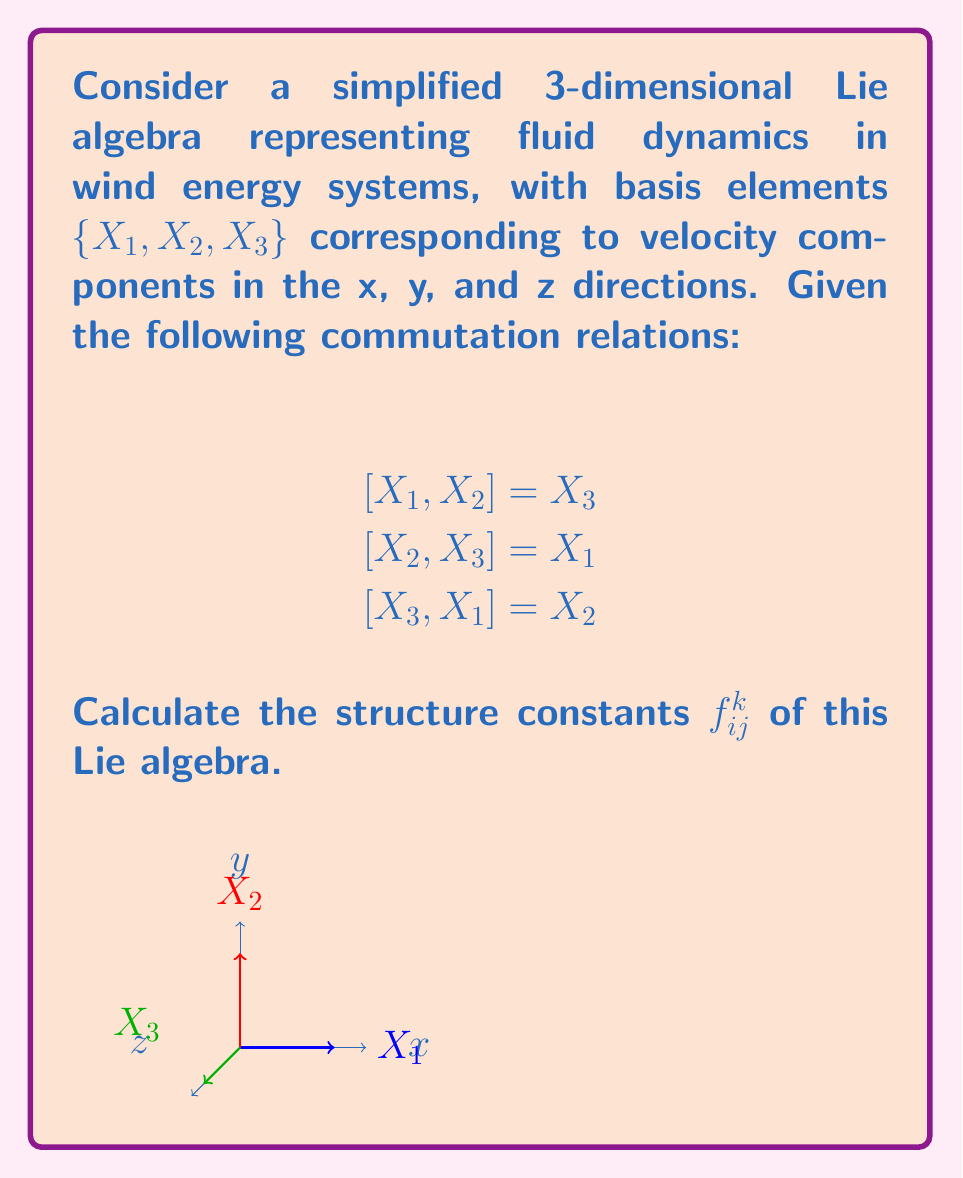Can you solve this math problem? To calculate the structure constants $f_{ij}^k$, we use the general form of the Lie bracket:

$$[X_i, X_j] = \sum_{k=1}^3 f_{ij}^k X_k$$

Step 1: Analyze $[X_1, X_2] = X_3$
This implies $f_{12}^3 = 1$, and $f_{12}^1 = f_{12}^2 = 0$

Step 2: Analyze $[X_2, X_3] = X_1$
This implies $f_{23}^1 = 1$, and $f_{23}^2 = f_{23}^3 = 0$

Step 3: Analyze $[X_3, X_1] = X_2$
This implies $f_{31}^2 = 1$, and $f_{31}^1 = f_{31}^3 = 0$

Step 4: Use the antisymmetry property of Lie brackets
$[X_i, X_j] = -[X_j, X_i]$ implies $f_{ij}^k = -f_{ji}^k$

Thus:
$f_{21}^3 = -1$, $f_{32}^1 = -1$, $f_{13}^2 = -1$

Step 5: All other structure constants are zero

Therefore, the non-zero structure constants are:
$f_{12}^3 = f_{23}^1 = f_{31}^2 = 1$
$f_{21}^3 = f_{32}^1 = f_{13}^2 = -1$
Answer: $f_{12}^3 = f_{23}^1 = f_{31}^2 = 1$, $f_{21}^3 = f_{32}^1 = f_{13}^2 = -1$, all others $= 0$ 